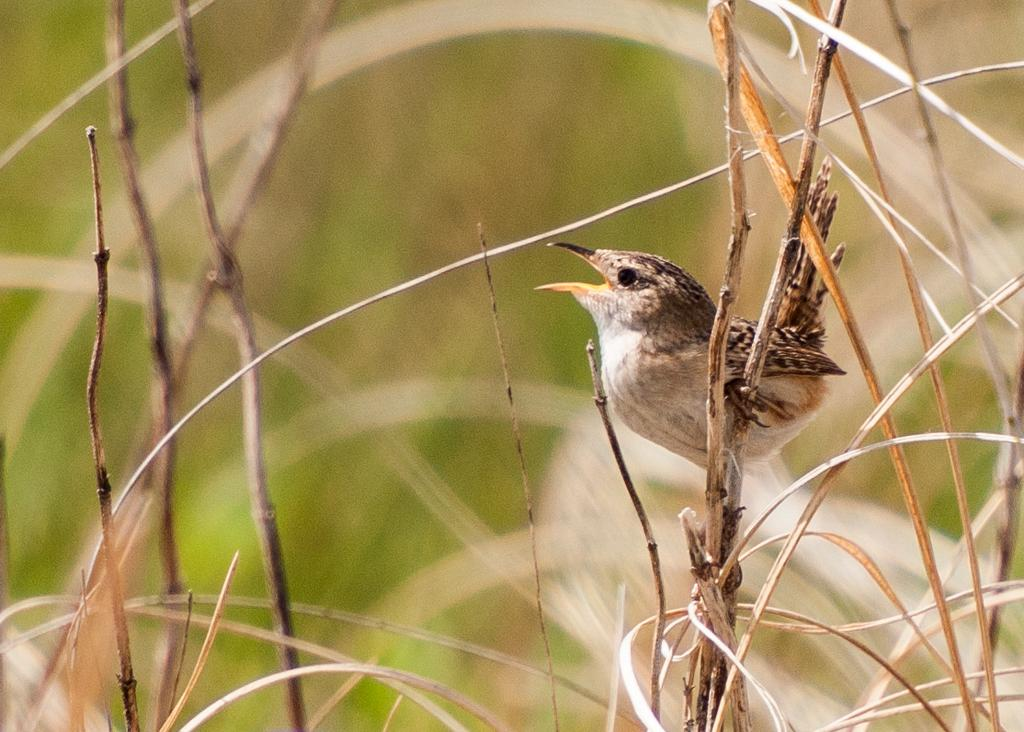What is the main subject of the image? The main subject of the image is a bird. How is the background of the image depicted? The background of the image is blurred. Are there any other elements present in the image besides the bird? Yes, there are dried stems of plants in the image. What type of insect can be seen interacting with the dried stems in the image? There is no insect present in the image; it features a bird and dried stems of plants. What division of the company is responsible for the creation of the image? The facts provided do not mention any company or division, so it is not possible to answer that question. 